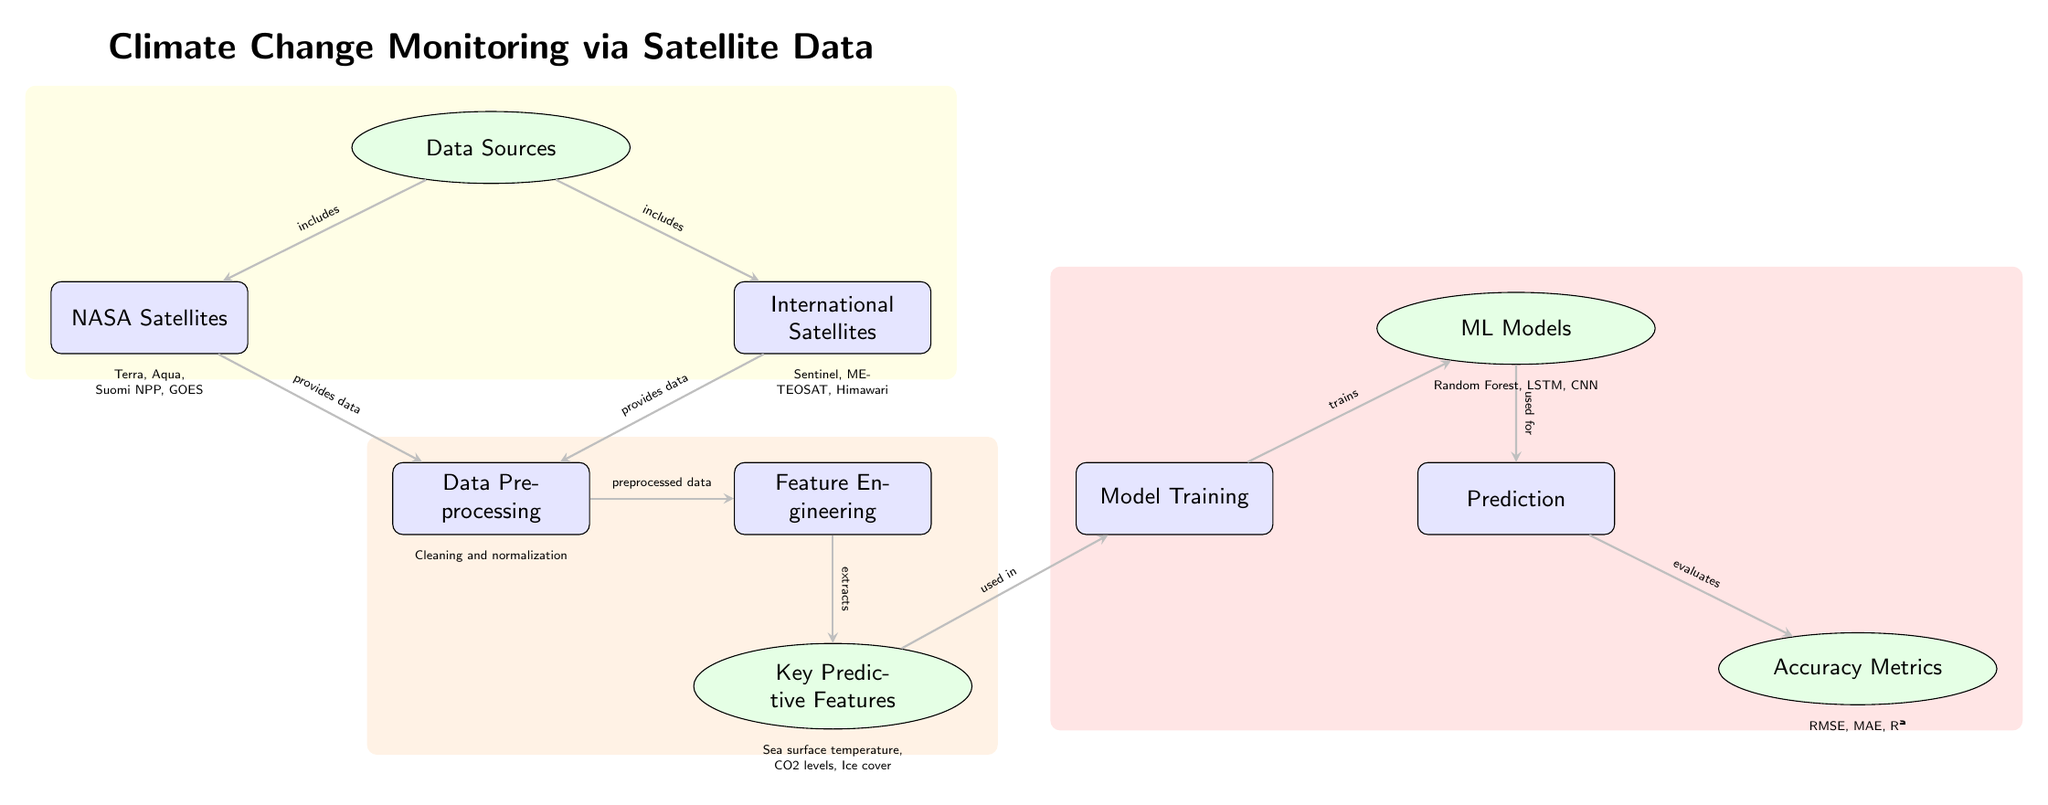What are the data sources for climate change monitoring? The diagram indicates that the "Data Sources" node is connected to two nodes: "NASA Satellites" and "External Satellites." Therefore, the data sources include both categories.
Answer: NASA Satellites, External Satellites Which key predictive feature is used in the model training? The arrow from the "Key Predictive Features" node to the "Model Training" node shows that the key predictive features are utilized in model training. The diagram lists specific features, such as sea surface temperature, CO2 levels, and ice cover.
Answer: Sea surface temperature, CO2 levels, Ice cover How many machine learning models are mentioned in the diagram? The "ML Models" node indicates the specific machine learning models used. The diagram specifies three models: Random Forest, LSTM, and CNN. Counting these, there are three machine learning models mentioned.
Answer: 3 What process follows data preprocessing? According to the diagram, after data preprocessing, the subsequent process is feature engineering, as indicated by the arrow connecting these two nodes.
Answer: Feature Engineering What accuracy metrics are evaluated after prediction? The diagram connects the "Prediction" node to the "Accuracy Metrics" node. It lists specific metrics such as RMSE, MAE, and R², which are evaluated after making predictions.
Answer: RMSE, MAE, R² Which node describes the actual training of the machine learning models? The arrow from the "Model Training" node points to the "ML Models" node, indicating that the training happens in the model training phase, which is specifically labeled in the diagram.
Answer: Model Training Which features are derived during feature engineering? The diagram includes a connection from the "Feature Engineering" node to the "Key Predictive Features" node, which shows that various features are extracted during this process. The specific features mentioned include sea surface temperature, CO2 levels, and ice cover.
Answer: Sea surface temperature, CO2 levels, Ice cover How do data sources contribute to data preprocessing? The diagram shows two arrows leading into the "Data Preprocessing" node from "NASA Satellites" and "External Satellites," indicating that data from both sources is fed into the preprocessing stage, thus contributing equally to this process.
Answer: Provides data Which node is the final evaluation stage in the diagram? The flow indicates that after predictions are made, the results are then evaluated in the "Accuracy Metrics" node, making it the final evaluation stage in the process depicted in the diagram.
Answer: Accuracy Metrics 